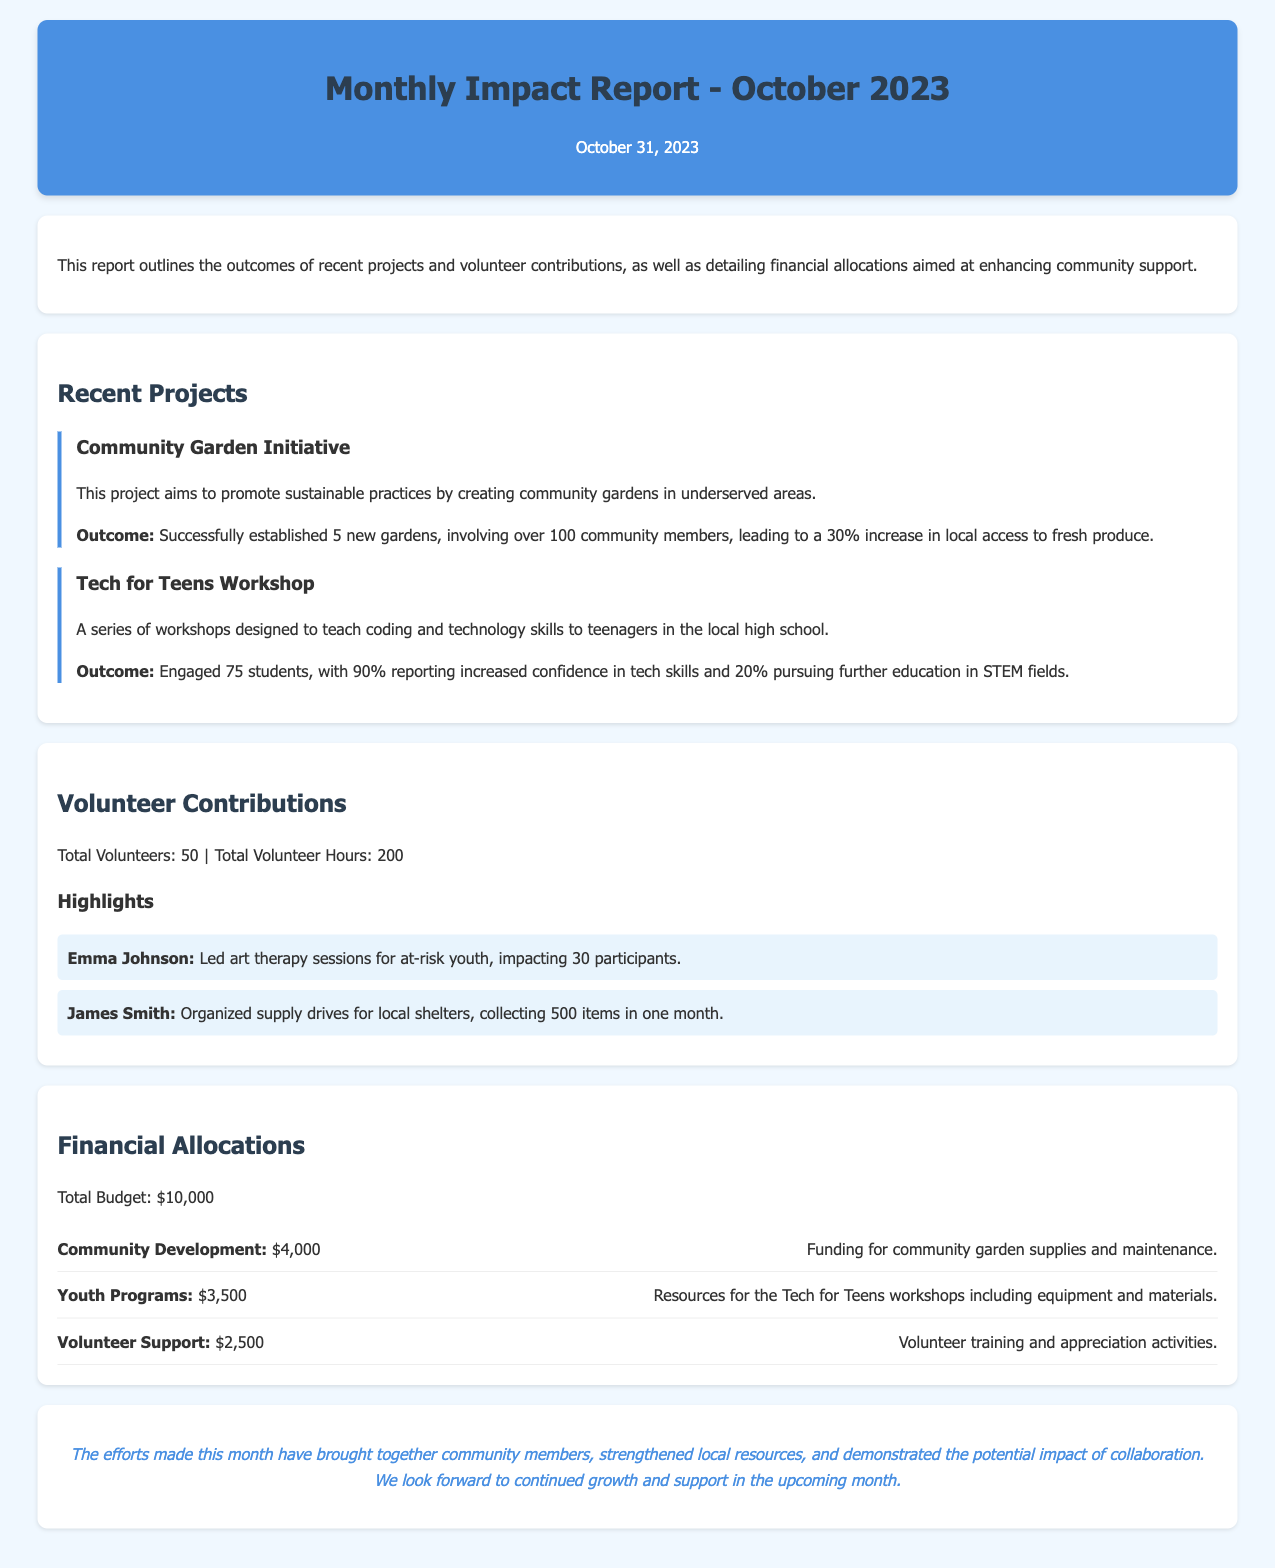What is the total number of volunteers? The total number of volunteers is stated as 50 in the document.
Answer: 50 What project led to a 30% increase in local access to fresh produce? This information can be found alongside the description of the Community Garden Initiative.
Answer: Community Garden Initiative How many community gardens were established? The document states that 5 new gardens were successfully established.
Answer: 5 What is the budget allocated for youth programs? The budget allocation for Youth Programs is listed as $3,500.
Answer: $3,500 Who organized supply drives for local shelters? This information is found in the highlights of volunteer contributions under James Smith’s activities.
Answer: James Smith What was the total number of volunteer hours recorded? The document specifies that the total volunteer hours are 200.
Answer: 200 What percentage of students reported increased confidence in tech skills? According to the Tech for Teens Workshop section, 90% of students reported increased confidence.
Answer: 90% Which volunteer led art therapy sessions? This detail is provided in the volunteer highlights section, referring to Emma Johnson.
Answer: Emma Johnson What financial allocation supports volunteer training? The financial allocation for volunteer support, including training, is mentioned as $2,500.
Answer: $2,500 